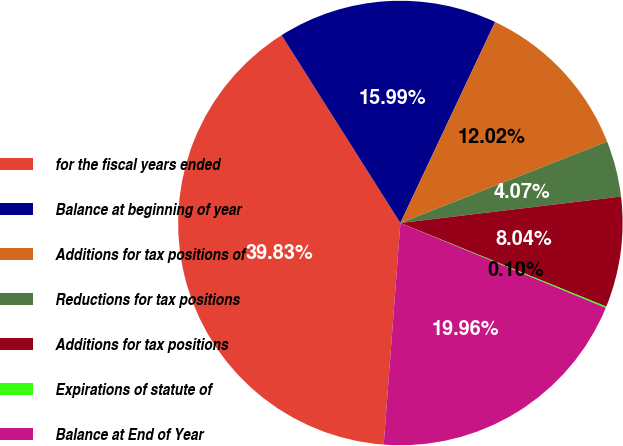<chart> <loc_0><loc_0><loc_500><loc_500><pie_chart><fcel>for the fiscal years ended<fcel>Balance at beginning of year<fcel>Additions for tax positions of<fcel>Reductions for tax positions<fcel>Additions for tax positions<fcel>Expirations of statute of<fcel>Balance at End of Year<nl><fcel>39.83%<fcel>15.99%<fcel>12.02%<fcel>4.07%<fcel>8.04%<fcel>0.1%<fcel>19.96%<nl></chart> 